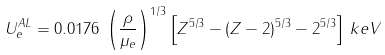Convert formula to latex. <formula><loc_0><loc_0><loc_500><loc_500>U _ { e } ^ { A L } = 0 . 0 1 7 6 \, \left ( \frac { \rho } { \mu _ { e } } \right ) ^ { 1 / 3 } \left [ Z ^ { 5 / 3 } - \left ( Z - 2 \right ) ^ { 5 / 3 } - 2 ^ { 5 / 3 } \right ] \, k e V</formula> 